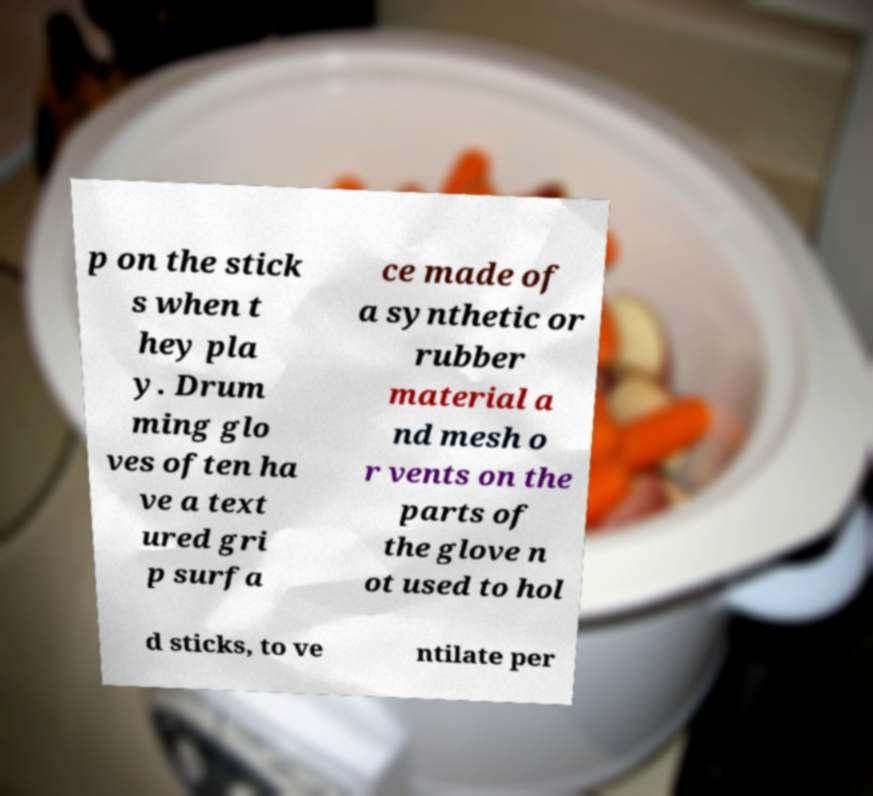For documentation purposes, I need the text within this image transcribed. Could you provide that? p on the stick s when t hey pla y. Drum ming glo ves often ha ve a text ured gri p surfa ce made of a synthetic or rubber material a nd mesh o r vents on the parts of the glove n ot used to hol d sticks, to ve ntilate per 